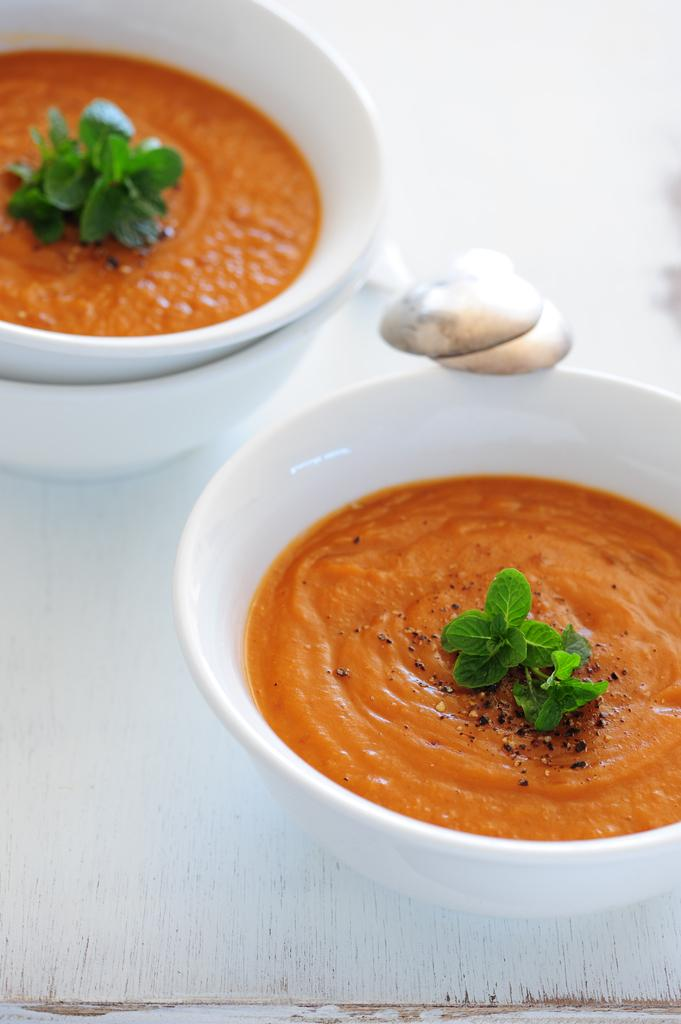What is in the bowls that are visible in the image? There are bowls with food in the image. What utensils are present in the image? There are spoons in the image. What color is the surface that the bowls and spoons are on? The surface the bowls and spoons are on is white. What type of paste is being used for arithmetic in the image? There is no paste or arithmetic activity present in the image; it features bowls with food and spoons on a white surface. 